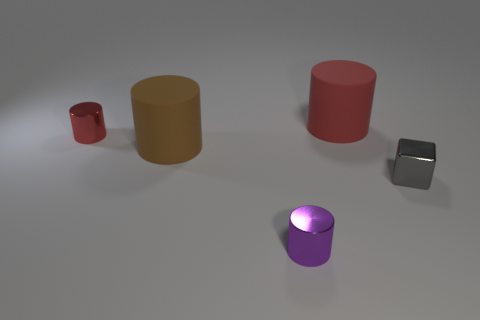Subtract all tiny red cylinders. How many cylinders are left? 3 Subtract all brown cylinders. How many cylinders are left? 3 Add 4 large brown blocks. How many objects exist? 9 Subtract all yellow balls. How many purple cubes are left? 0 Subtract all cylinders. How many objects are left? 1 Subtract all purple blocks. Subtract all cyan spheres. How many blocks are left? 1 Subtract all gray blocks. Subtract all red objects. How many objects are left? 2 Add 3 gray things. How many gray things are left? 4 Add 1 big things. How many big things exist? 3 Subtract 0 cyan balls. How many objects are left? 5 